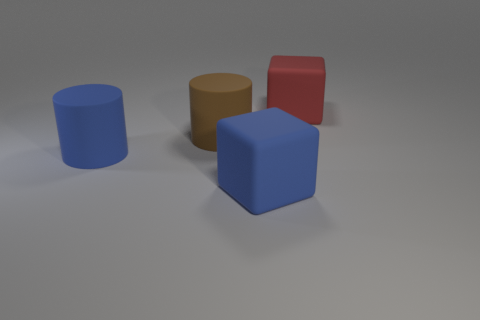Add 3 yellow rubber cubes. How many objects exist? 7 Subtract 2 cubes. How many cubes are left? 0 Subtract all purple cubes. Subtract all cyan cylinders. How many cubes are left? 2 Subtract all brown spheres. How many red blocks are left? 1 Subtract 0 green spheres. How many objects are left? 4 Subtract all matte blocks. Subtract all red objects. How many objects are left? 1 Add 4 red things. How many red things are left? 5 Add 4 big things. How many big things exist? 8 